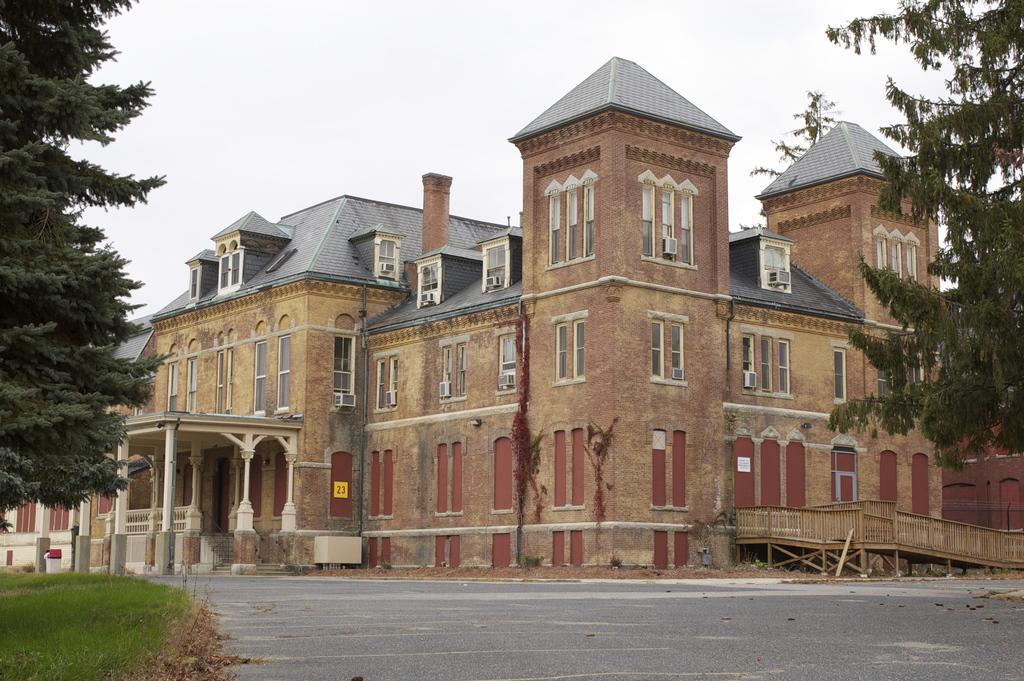Can you describe this image briefly? In the image there is a road in the foreground and behind the road there is an architecture and around that there is grass and trees. 